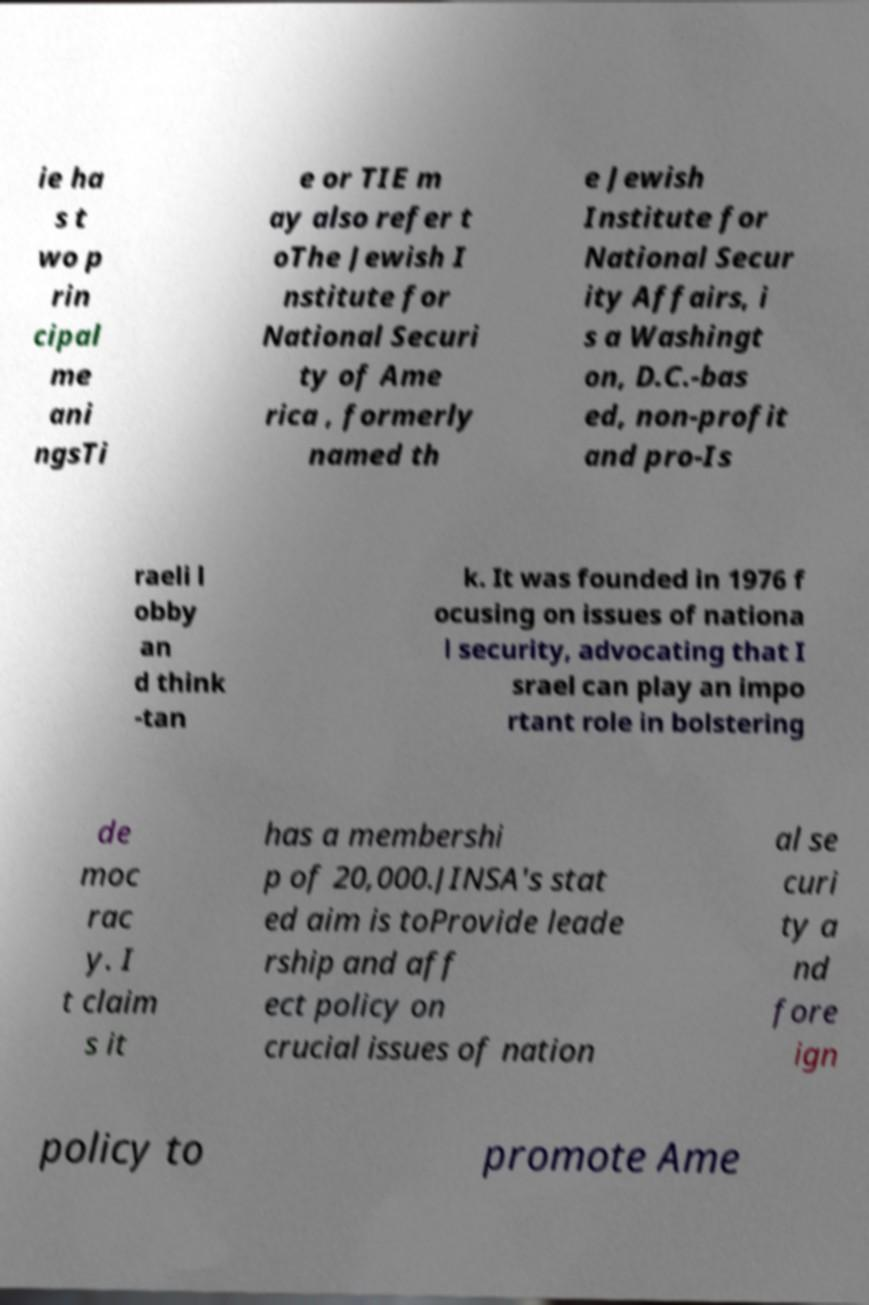Could you extract and type out the text from this image? ie ha s t wo p rin cipal me ani ngsTi e or TIE m ay also refer t oThe Jewish I nstitute for National Securi ty of Ame rica , formerly named th e Jewish Institute for National Secur ity Affairs, i s a Washingt on, D.C.-bas ed, non-profit and pro-Is raeli l obby an d think -tan k. It was founded in 1976 f ocusing on issues of nationa l security, advocating that I srael can play an impo rtant role in bolstering de moc rac y. I t claim s it has a membershi p of 20,000.JINSA's stat ed aim is toProvide leade rship and aff ect policy on crucial issues of nation al se curi ty a nd fore ign policy to promote Ame 